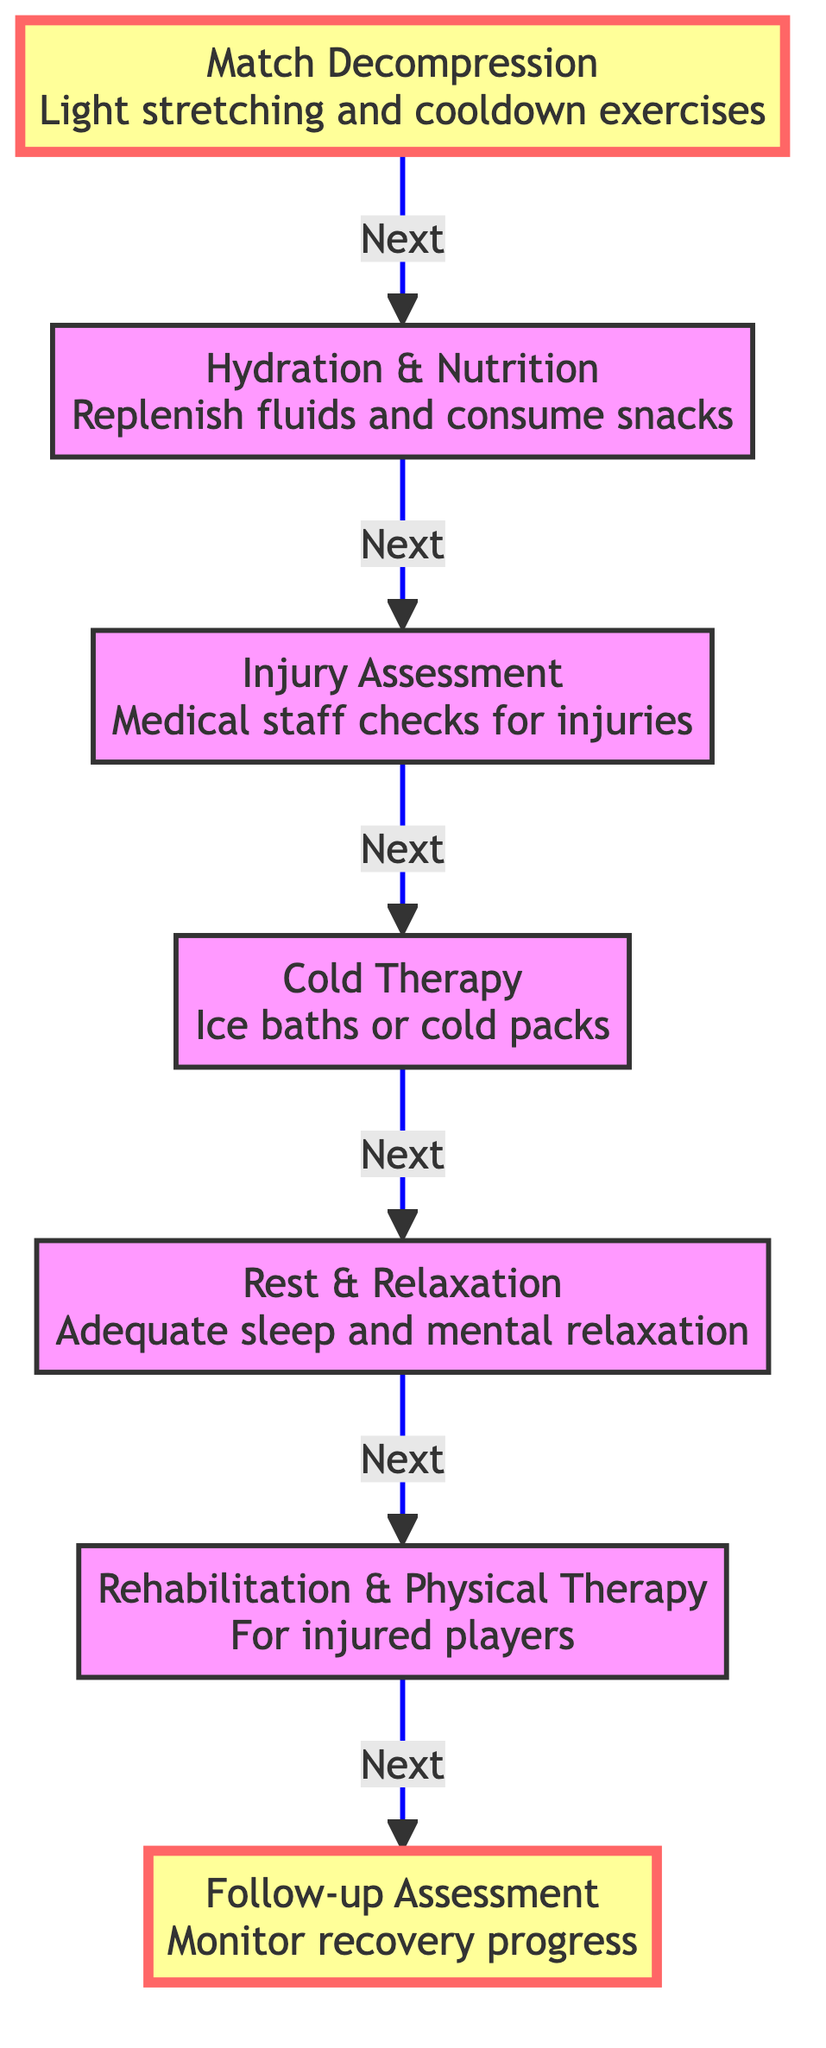What is the first step in post-match recovery? The diagram indicates that the first step is "Match Decompression", which includes light stretching and cooldown exercises to help reduce muscle stiffness.
Answer: Match Decompression How many main steps are there in the post-match recovery process? To find the number of main steps, I count the nodes starting from "Match Decompression" to the final "Follow-up Assessment". There are a total of seven steps.
Answer: Seven What activity follows "Cold Therapy"? The arrows in the diagram show that the activity following "Cold Therapy" is "Rest & Relaxation", where players are encouraged to get adequate sleep and relaxation.
Answer: Rest & Relaxation What is the final step of the recovery process? The last node in the flowchart is "Follow-up Assessment", indicating that this is the final step of the recovery process where players' recovery progress is monitored.
Answer: Follow-up Assessment What are players encouraged to do during the "Rest & Relaxation" phase? According to the diagram, during the "Rest & Relaxation" phase, players are encouraged to get adequate sleep and mental relaxation to facilitate recovery.
Answer: Get adequate sleep and mental relaxation What step comes directly before "Rehabilitation & Physical Therapy"? The diagram shows that "Rest & Relaxation" comes directly before "Rehabilitation & Physical Therapy", marking it as the preceding step in the recovery process.
Answer: Rest & Relaxation What is assessed in the "Injury Assessment" step? The diagram specifically states that during the "Injury Assessment" step, medical staff checks for injuries and provides immediate treatment if necessary.
Answer: Players for injuries What are the two types of recovery support provided immediately after a match? Reviewing the diagram, the two immediate recovery support types listed are "Match Decompression" and "Hydration & Nutrition", which help players transition from match to recovery.
Answer: Match Decompression and Hydration & Nutrition What is the purpose of "Cold Therapy" in the recovery process? In the flowchart, "Cold Therapy" is intended to reduce inflammation and muscle soreness for the players who have just completed a match.
Answer: Reduce inflammation and muscle soreness 